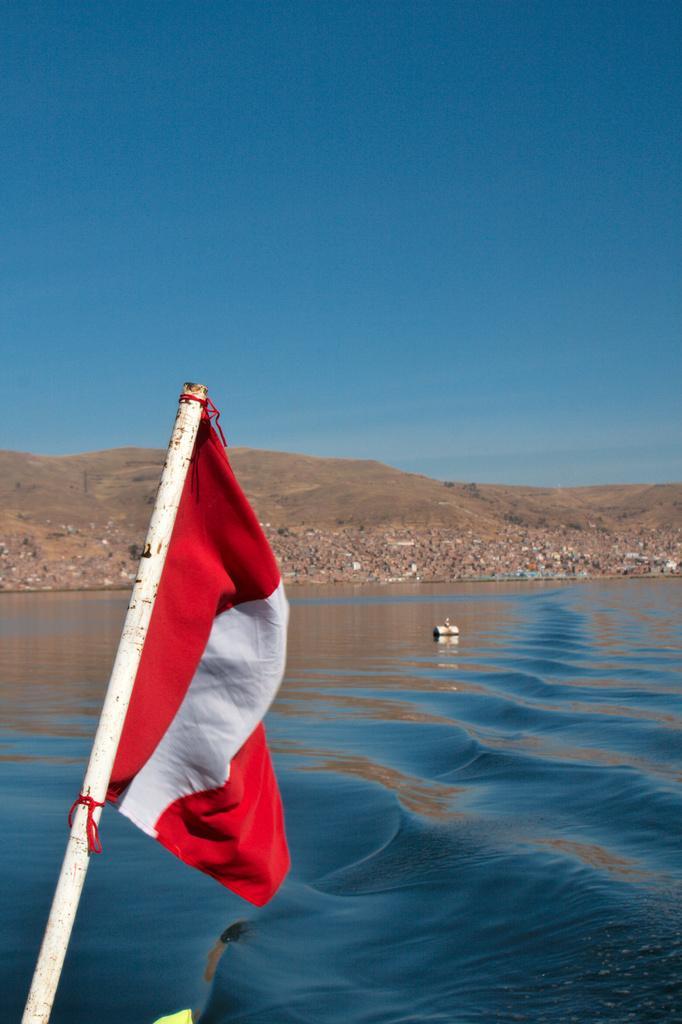How would you summarize this image in a sentence or two? In this picture there is a flag on the left side of the image and there is water in the center of the image. 